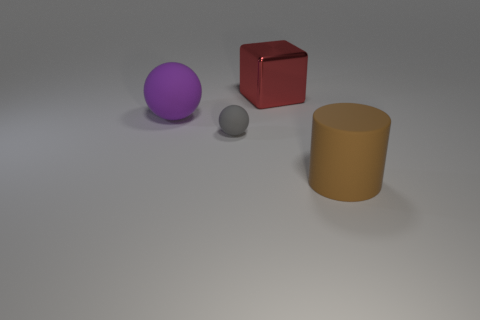There is another object that is the same shape as the purple object; what is its size?
Provide a short and direct response. Small. There is a sphere in front of the large rubber object behind the small gray matte object; how many big cubes are right of it?
Provide a short and direct response. 1. Is the number of tiny objects on the left side of the small rubber thing the same as the number of large things?
Provide a short and direct response. No. What number of cubes are large brown matte things or tiny things?
Give a very brief answer. 0. Is the big sphere the same color as the big cylinder?
Make the answer very short. No. Are there an equal number of large red shiny things that are to the left of the big red metallic cube and gray things behind the large purple rubber ball?
Keep it short and to the point. Yes. The metal block is what color?
Provide a short and direct response. Red. How many objects are either big matte objects that are in front of the big purple rubber sphere or tiny yellow rubber cubes?
Ensure brevity in your answer.  1. There is a rubber object right of the shiny cube; is its size the same as the gray sphere that is to the left of the large red cube?
Keep it short and to the point. No. Are there any other things that are the same material as the big brown thing?
Provide a short and direct response. Yes. 